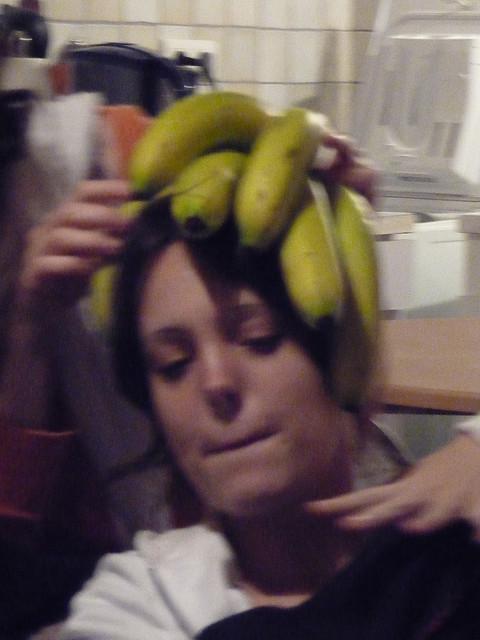How many people are visible?
Give a very brief answer. 2. How many bananas are there?
Give a very brief answer. 4. How many umbrellas do you see?
Give a very brief answer. 0. 